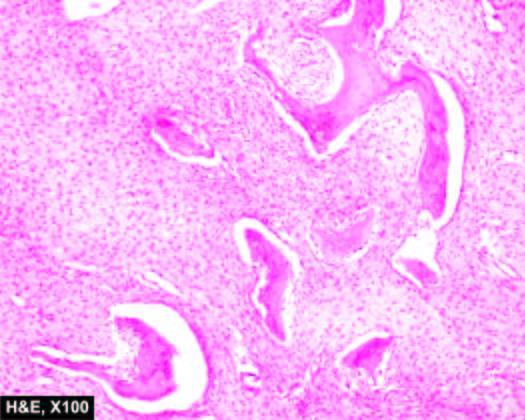what have fish-hook appearance surrounded by fibrous tissue?
Answer the question using a single word or phrase. Bony trabeculae 